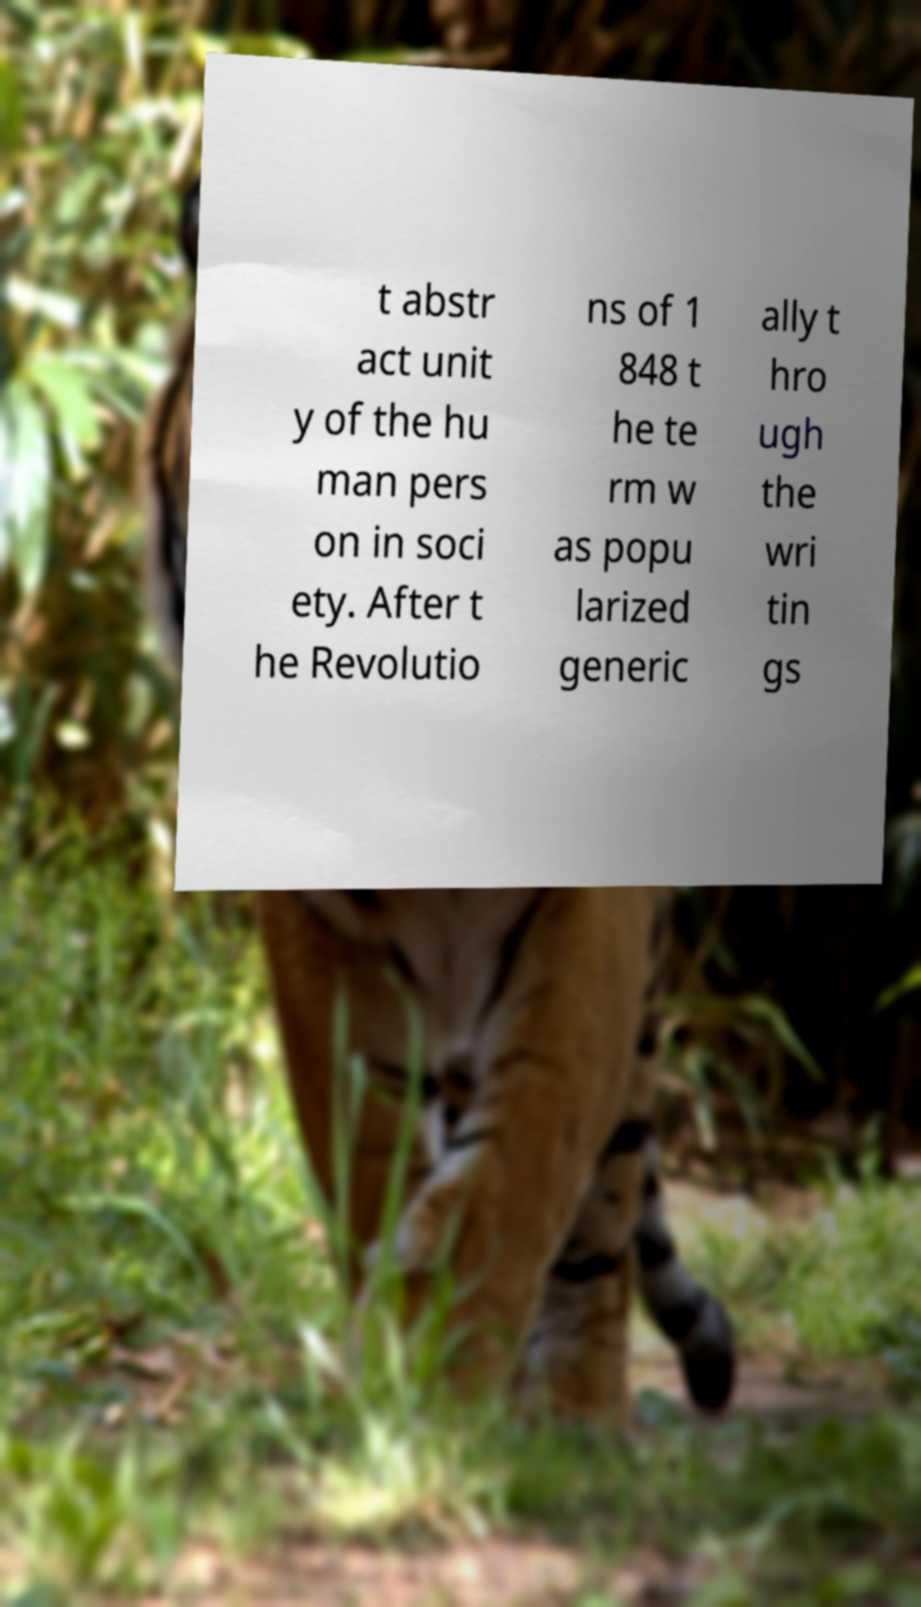There's text embedded in this image that I need extracted. Can you transcribe it verbatim? t abstr act unit y of the hu man pers on in soci ety. After t he Revolutio ns of 1 848 t he te rm w as popu larized generic ally t hro ugh the wri tin gs 